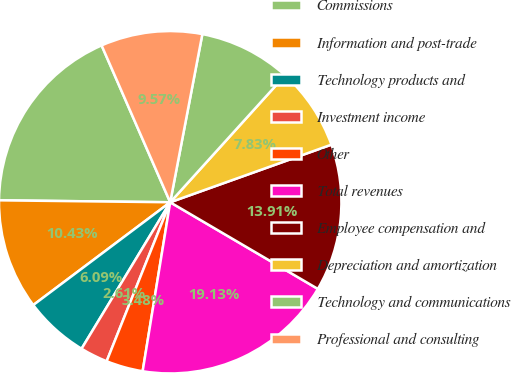Convert chart. <chart><loc_0><loc_0><loc_500><loc_500><pie_chart><fcel>Commissions<fcel>Information and post-trade<fcel>Technology products and<fcel>Investment income<fcel>Other<fcel>Total revenues<fcel>Employee compensation and<fcel>Depreciation and amortization<fcel>Technology and communications<fcel>Professional and consulting<nl><fcel>18.26%<fcel>10.43%<fcel>6.09%<fcel>2.61%<fcel>3.48%<fcel>19.13%<fcel>13.91%<fcel>7.83%<fcel>8.7%<fcel>9.57%<nl></chart> 